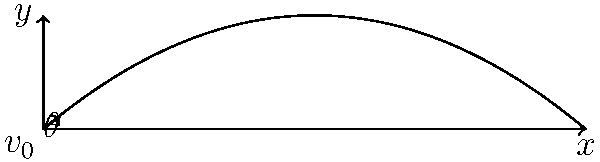During a discus throw competition you're reporting on, an athlete launches a discus with an initial velocity of 25 m/s at an angle of 40° above the horizontal. Assuming no air resistance, calculate the maximum height reached by the discus during its flight. To find the maximum height of the discus, we'll follow these steps:

1) First, we need to determine the vertical component of the initial velocity:
   $v_{0y} = v_0 \sin(\theta) = 25 \sin(40°) = 16.07$ m/s

2) The time to reach the maximum height is when the vertical velocity becomes zero:
   $t_{max} = \frac{v_{0y}}{g} = \frac{16.07}{9.8} = 1.64$ s

3) Now we can use the equation for displacement in the vertical direction:
   $y = v_{0y}t - \frac{1}{2}gt^2$

4) Substituting our values:
   $y_{max} = (16.07)(1.64) - \frac{1}{2}(9.8)(1.64)^2$
   $y_{max} = 26.35 - 13.17 = 13.18$ m

Therefore, the maximum height reached by the discus is approximately 13.18 meters.
Answer: 13.18 m 